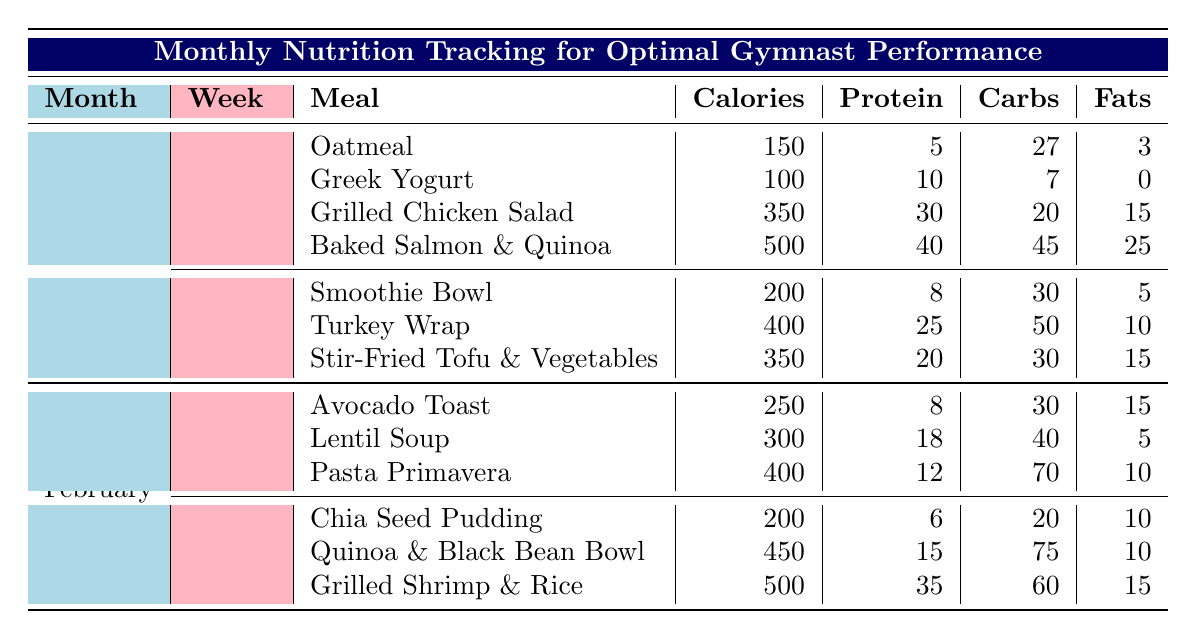What is the total calorie intake for Week 1 of January? The calorie contents from each meal in Week 1 of January are as follows: Oatmeal (150), Greek Yogurt (100), Grilled Chicken Salad (350), and Baked Salmon & Quinoa (500). To find the total, sum these values: 150 + 100 + 350 + 500 = 1100.
Answer: 1100 Which meal has the highest protein content in February? From the meals listed in February, the protein amounts are: Avocado Toast (8), Lentil Soup (18), Pasta Primavera (12), Chia Seed Pudding (6), Quinoa & Black Bean Bowl (15), and Grilled Shrimp & Rice (35). The highest protein value is from Grilled Shrimp & Rice, which contains 35 grams of protein.
Answer: Grilled Shrimp & Rice Is the total carbohydrate content for Week 2 in January greater than 100 grams? In Week 2 of January, the carbohydrate contents from each meal are: Smoothie Bowl (30), Turkey Wrap (50), and Stir-Fried Tofu & Vegetables (30). The total carbohydrate intake is 30 + 50 + 30 = 110, which is greater than 100.
Answer: Yes What is the average fat content of the meals in January? The fat contents of the meals in January are: Oatmeal (3), Greek Yogurt (0), Grilled Chicken Salad (15), Baked Salmon & Quinoa (25), Smoothie Bowl (5), Turkey Wrap (10), and Stir-Fried Tofu & Vegetables (15). To find the average, first sum the values: 3 + 0 + 15 + 25 + 5 + 10 + 15 = 73. There are 7 meals, so the average fat content is 73/7 ≈ 10.43.
Answer: 10.43 How many meals in February contain more than 400 calories? The meals in February and their calorie values are: Avocado Toast (250), Lentil Soup (300), Pasta Primavera (400), Chia Seed Pudding (200), Quinoa & Black Bean Bowl (450), and Grilled Shrimp & Rice (500). The meals over 400 calories are Quinoa & Black Bean Bowl (450) and Grilled Shrimp & Rice (500), totaling 2 meals.
Answer: 2 